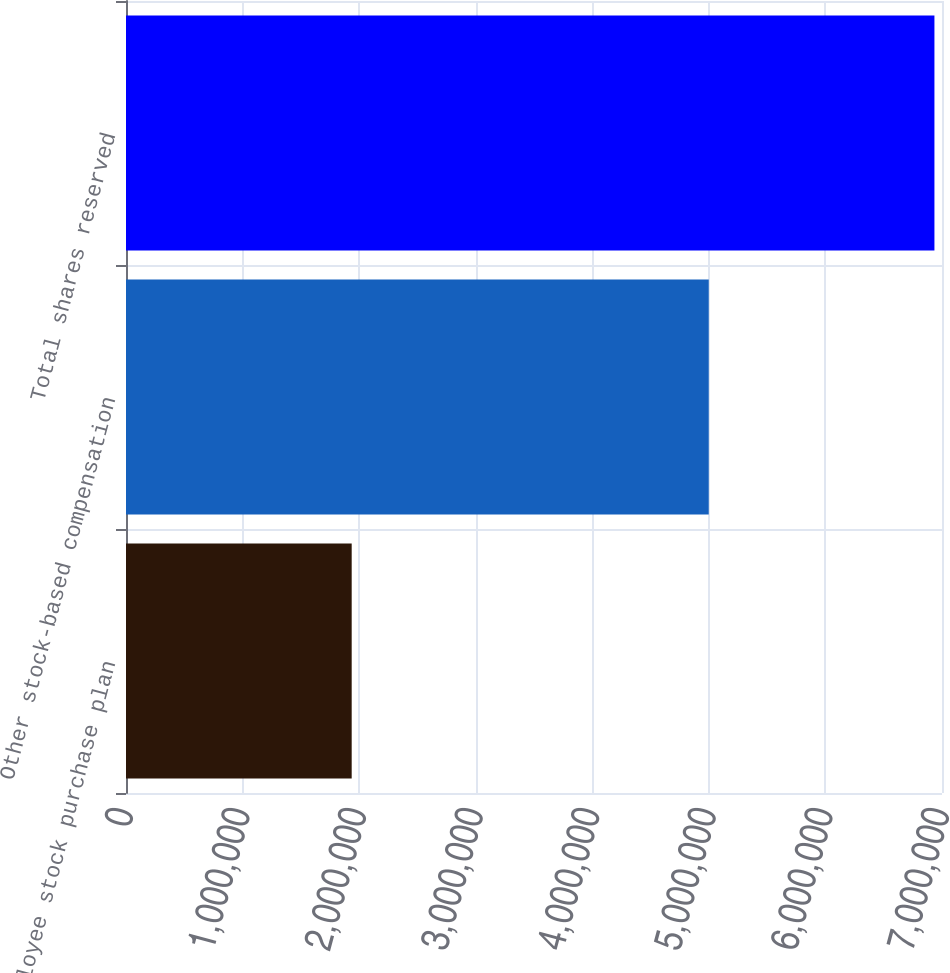Convert chart. <chart><loc_0><loc_0><loc_500><loc_500><bar_chart><fcel>Employee stock purchase plan<fcel>Other stock-based compensation<fcel>Total shares reserved<nl><fcel>1.93609e+06<fcel>4.99898e+06<fcel>6.93508e+06<nl></chart> 